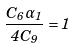Convert formula to latex. <formula><loc_0><loc_0><loc_500><loc_500>\frac { C _ { 6 } \alpha _ { 1 } } { 4 C _ { 9 } } = 1</formula> 